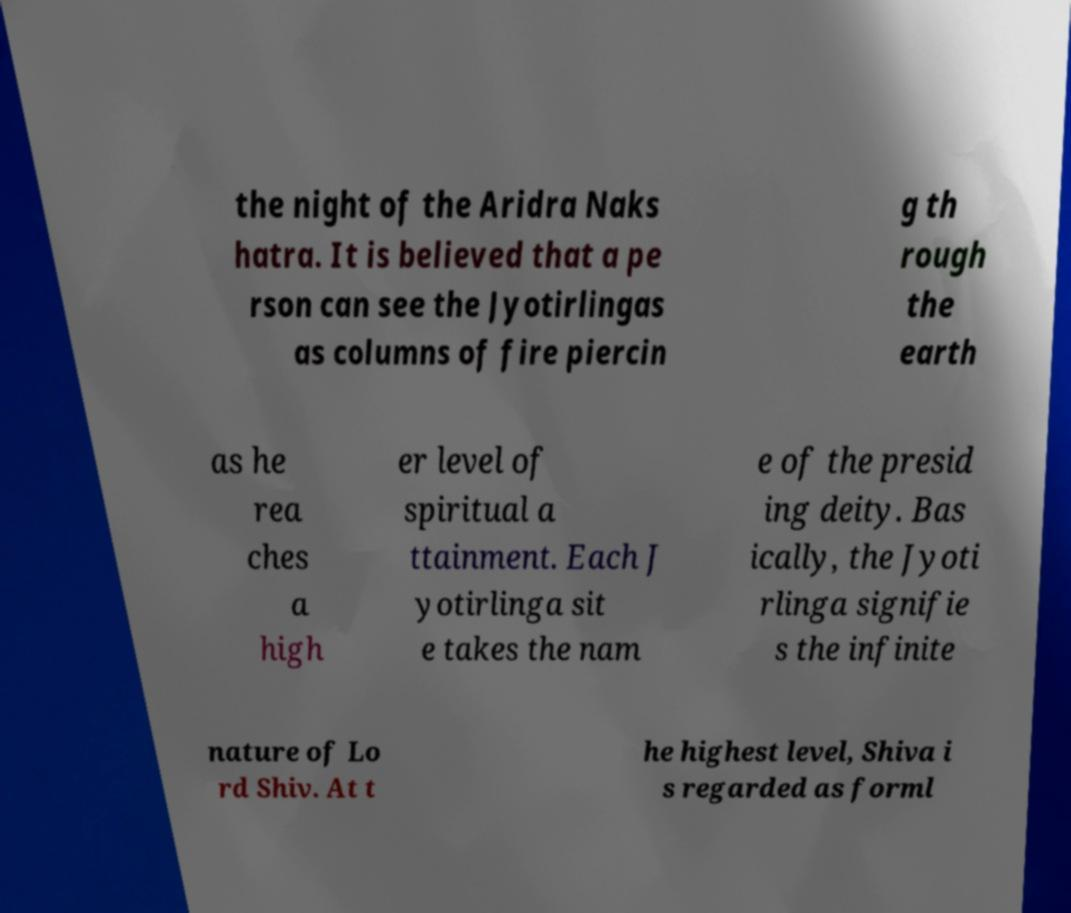There's text embedded in this image that I need extracted. Can you transcribe it verbatim? the night of the Aridra Naks hatra. It is believed that a pe rson can see the Jyotirlingas as columns of fire piercin g th rough the earth as he rea ches a high er level of spiritual a ttainment. Each J yotirlinga sit e takes the nam e of the presid ing deity. Bas ically, the Jyoti rlinga signifie s the infinite nature of Lo rd Shiv. At t he highest level, Shiva i s regarded as forml 